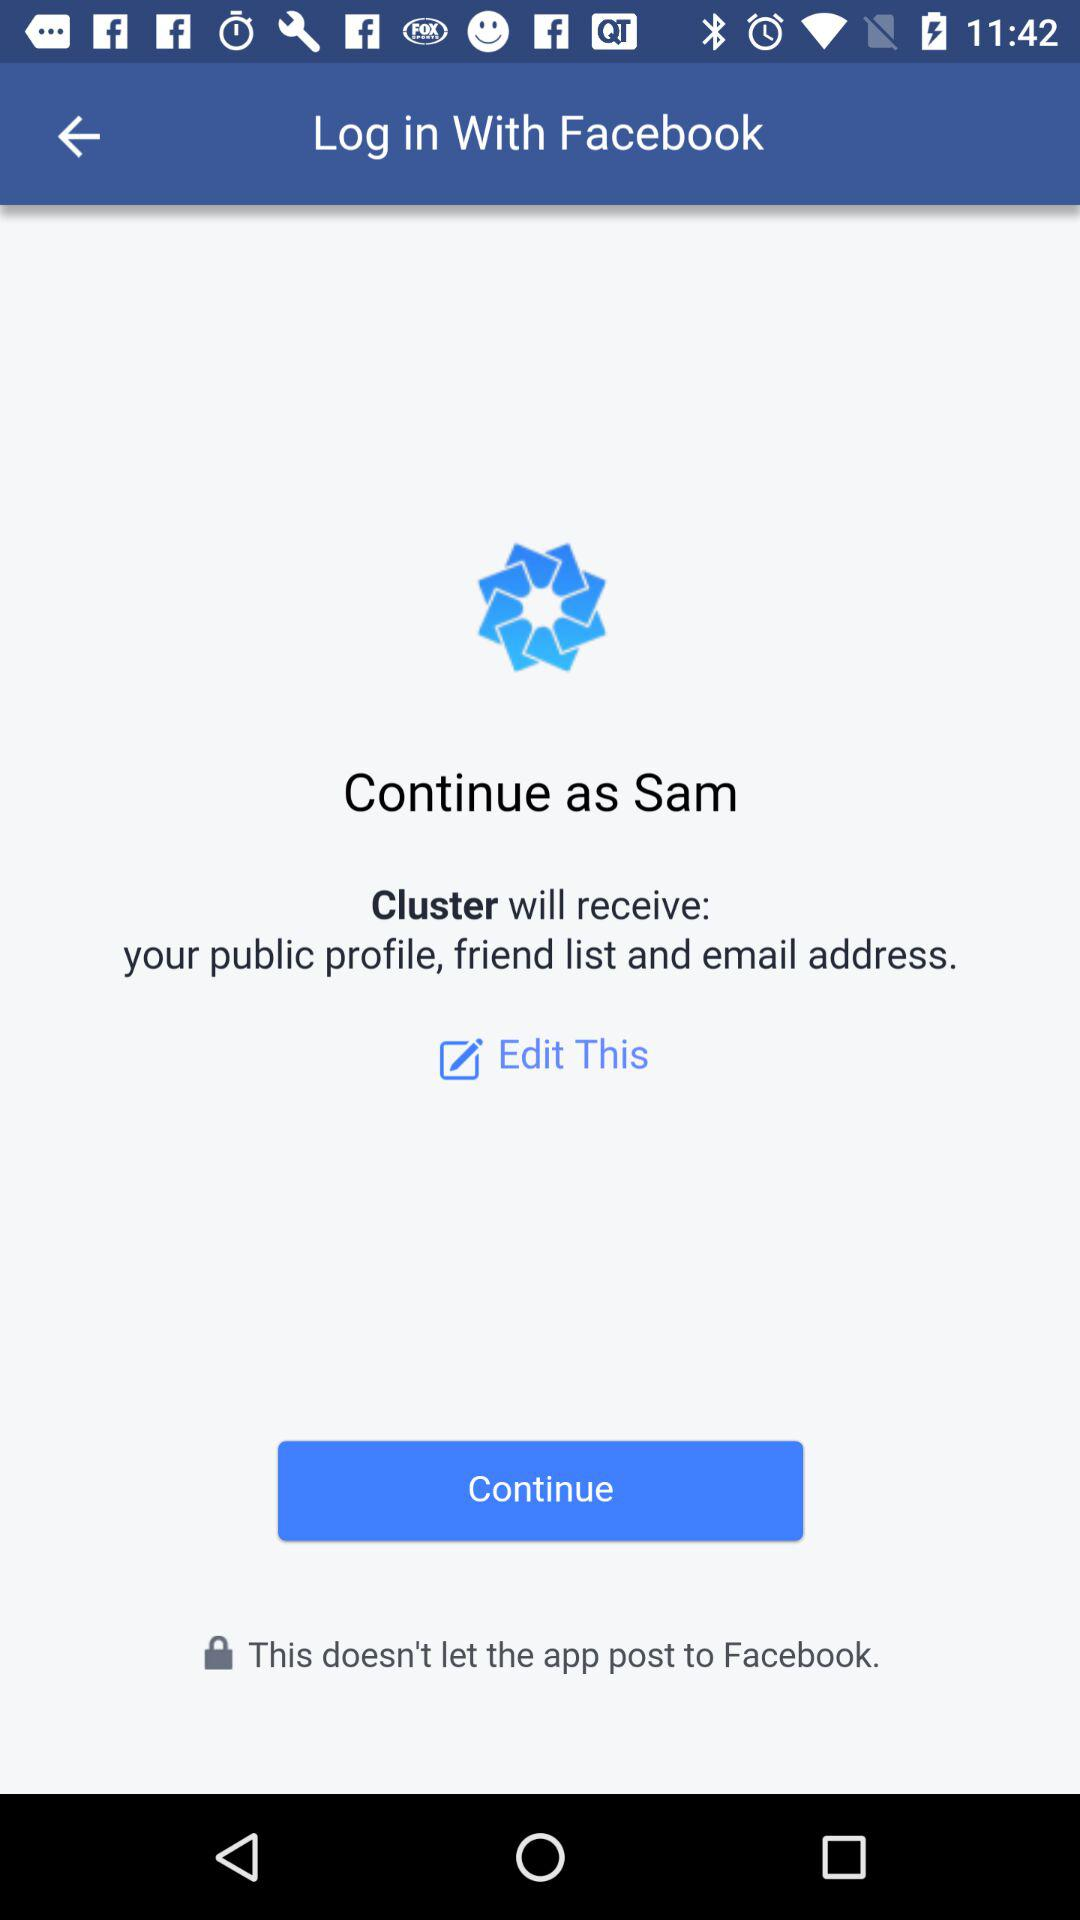What is the user name? The user name is Sam. 